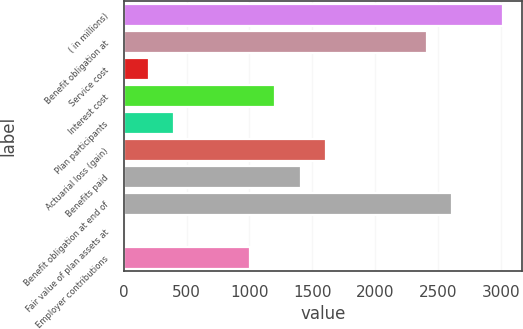Convert chart. <chart><loc_0><loc_0><loc_500><loc_500><bar_chart><fcel>( in millions)<fcel>Benefit obligation at<fcel>Service cost<fcel>Interest cost<fcel>Plan participants<fcel>Actuarial loss (gain)<fcel>Benefits paid<fcel>Benefit obligation at end of<fcel>Fair value of plan assets at<fcel>Employer contributions<nl><fcel>3017.5<fcel>2414.2<fcel>202.1<fcel>1207.6<fcel>403.2<fcel>1609.8<fcel>1408.7<fcel>2615.3<fcel>1<fcel>1006.5<nl></chart> 